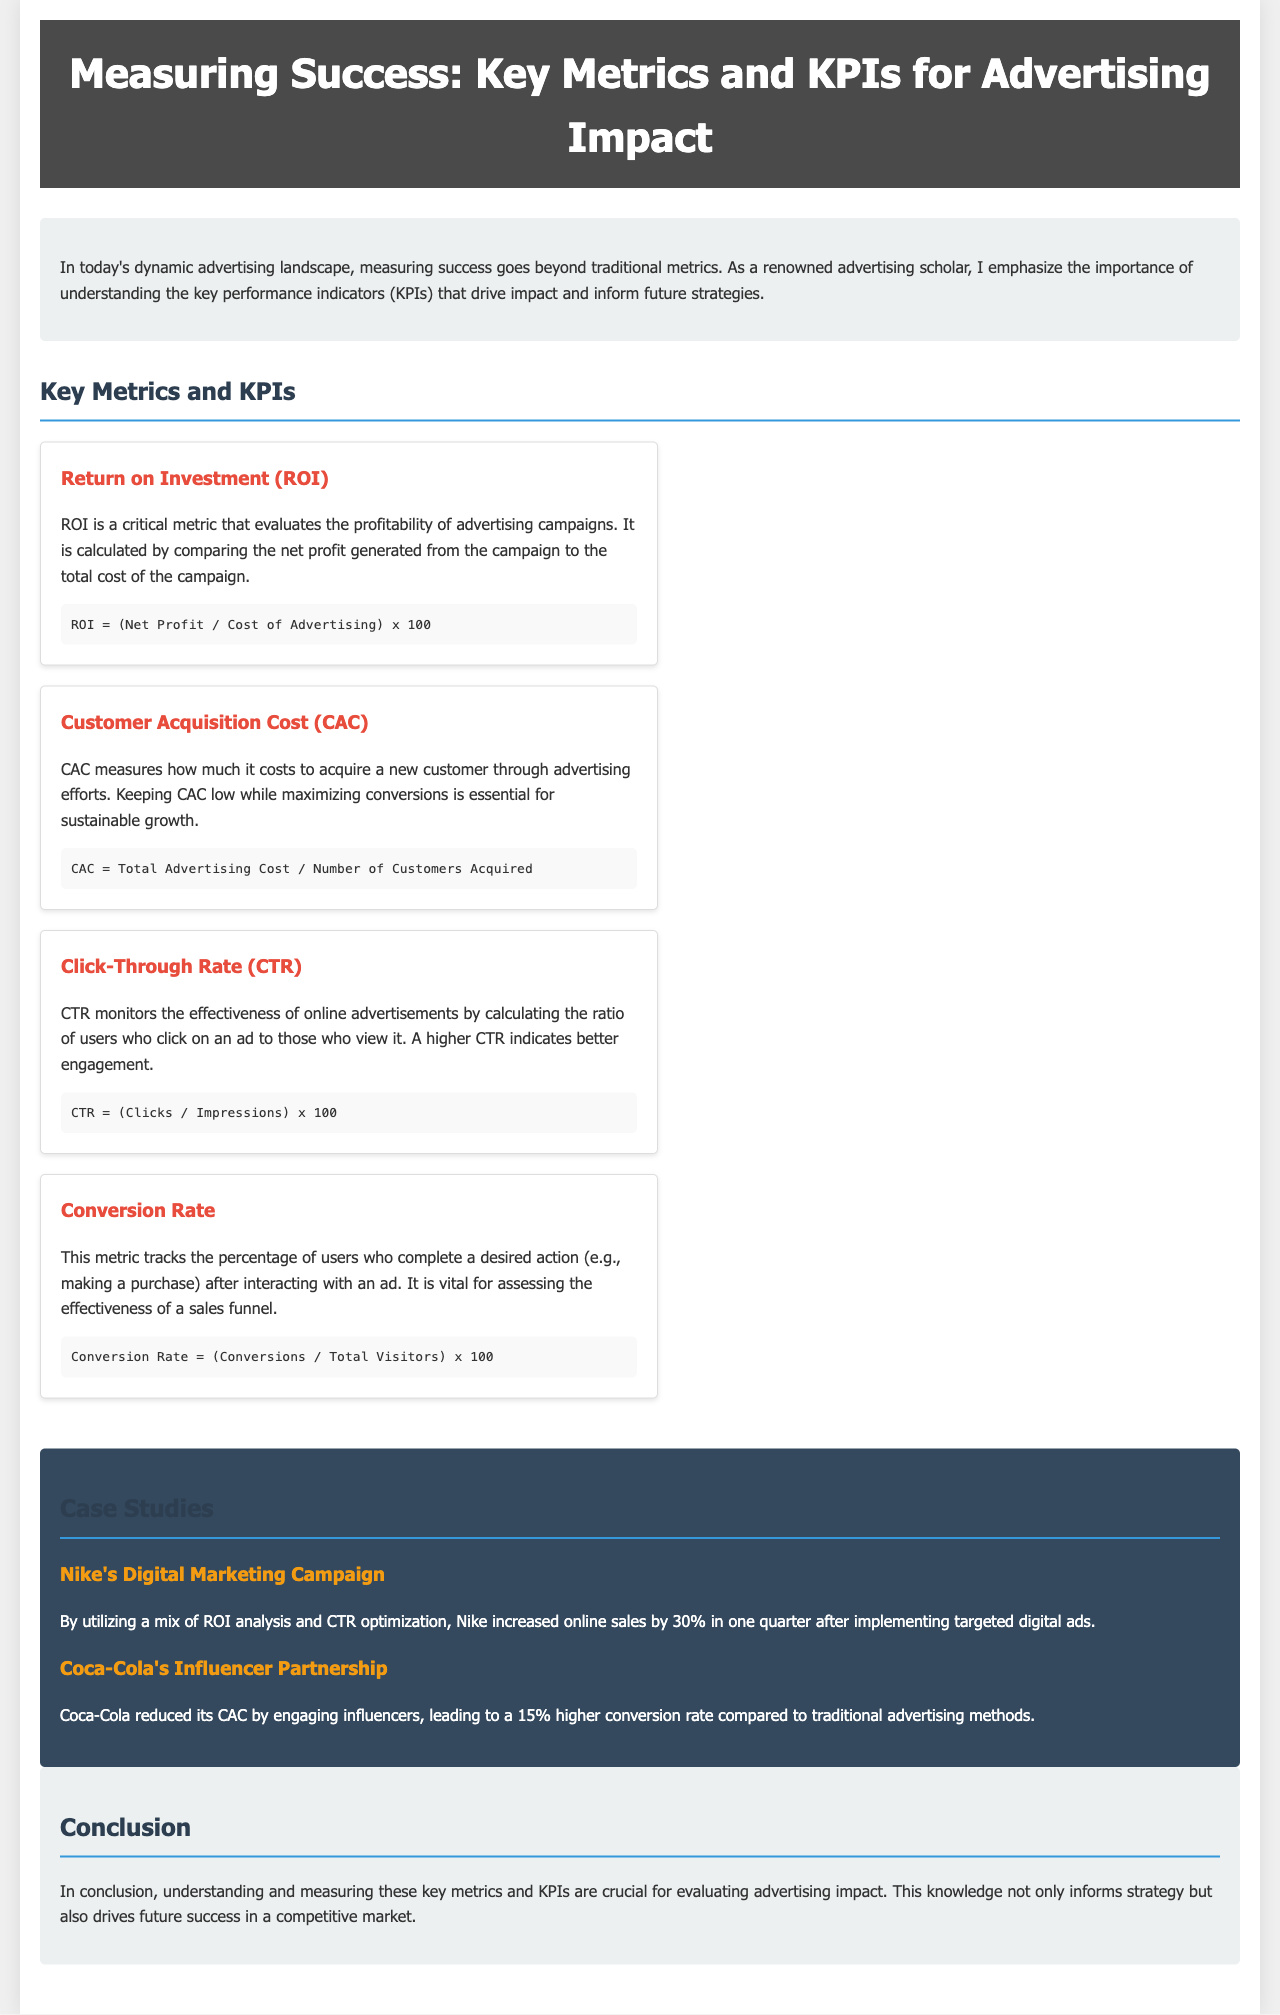What is the title of the brochure? The title of the brochure is mentioned at the top of the document.
Answer: Measuring Success: Key Metrics and KPIs for Advertising Impact What metric measures the profitability of advertising campaigns? The document defines a specific metric related to profitability within the context of advertising campaigns.
Answer: Return on Investment (ROI) Which metric is used to track the percentage of users completing a desired action? There is a specific metric described that focuses on user actions following ad interactions.
Answer: Conversion Rate What is the formula for calculating Click-Through Rate (CTR)? The document provides the mathematical formula used to calculate CTR in an ad context.
Answer: CTR = (Clicks / Impressions) x 100 What improvement did Nike achieve through its digital marketing campaign? The document includes a case study that highlights a specific numerical improvement in sales due to advertising efforts.
Answer: 30% How did Coca-Cola enhance its advertising effectiveness? The case study on Coca-Cola describes a specific approach that improved its advertising metric, which is related to cost.
Answer: Engaging influencers What does CAC stand for? The acronym is defined within the document, relating to advertising costs.
Answer: Customer Acquisition Cost In which section are the case studies mentioned? The document is structured with specific sections; one of them is relevant for case studies.
Answer: Case Studies What color is used for the header background? The style of the document specifies a distinct color for the header, which is a part of its design.
Answer: Dark gray 